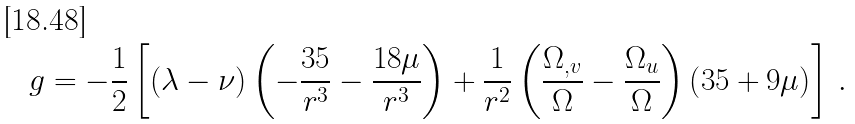Convert formula to latex. <formula><loc_0><loc_0><loc_500><loc_500>g = - \frac { 1 } { 2 } \left [ \left ( \lambda - \nu \right ) \left ( - \frac { 3 5 } { r ^ { 3 } } - \frac { 1 8 \mu } { r ^ { 3 } } \right ) + \frac { 1 } { r ^ { 2 } } \left ( \frac { \Omega _ { , v } } { \Omega } - \frac { \Omega _ { u } } { \Omega } \right ) \left ( 3 5 + 9 \mu \right ) \right ] \, .</formula> 